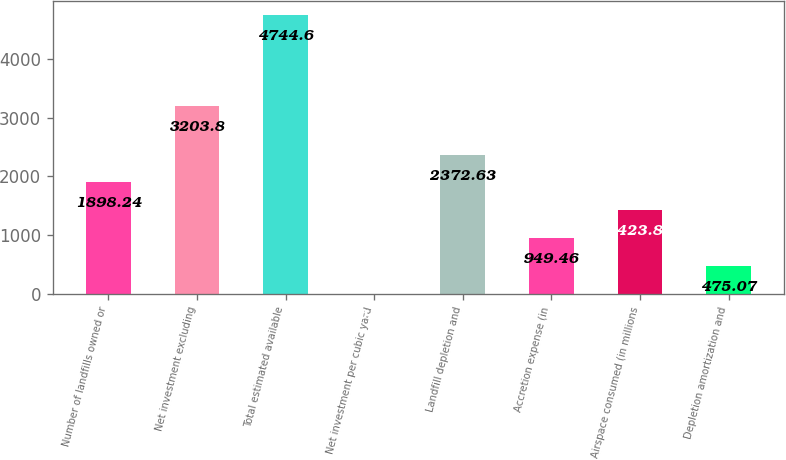Convert chart. <chart><loc_0><loc_0><loc_500><loc_500><bar_chart><fcel>Number of landfills owned or<fcel>Net investment excluding<fcel>Total estimated available<fcel>Net investment per cubic yard<fcel>Landfill depletion and<fcel>Accretion expense (in<fcel>Airspace consumed (in millions<fcel>Depletion amortization and<nl><fcel>1898.24<fcel>3203.8<fcel>4744.6<fcel>0.68<fcel>2372.63<fcel>949.46<fcel>1423.85<fcel>475.07<nl></chart> 